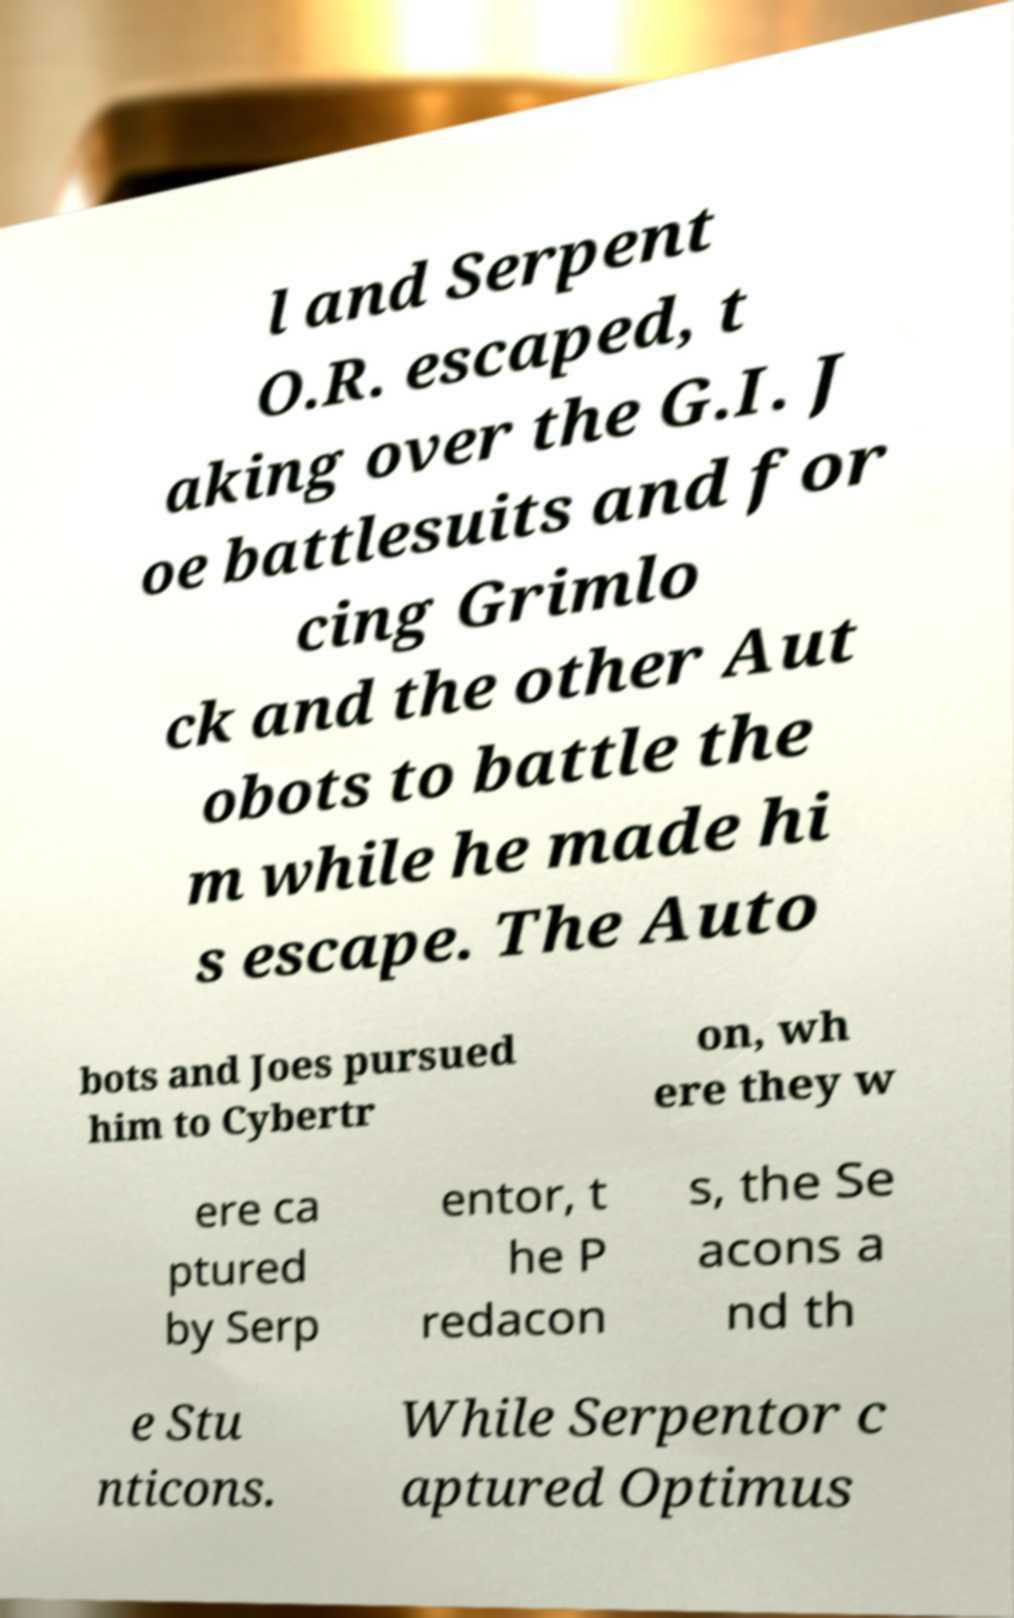Can you accurately transcribe the text from the provided image for me? l and Serpent O.R. escaped, t aking over the G.I. J oe battlesuits and for cing Grimlo ck and the other Aut obots to battle the m while he made hi s escape. The Auto bots and Joes pursued him to Cybertr on, wh ere they w ere ca ptured by Serp entor, t he P redacon s, the Se acons a nd th e Stu nticons. While Serpentor c aptured Optimus 